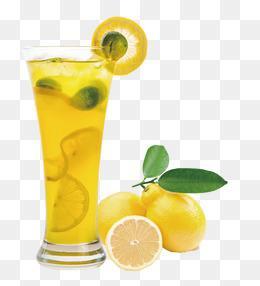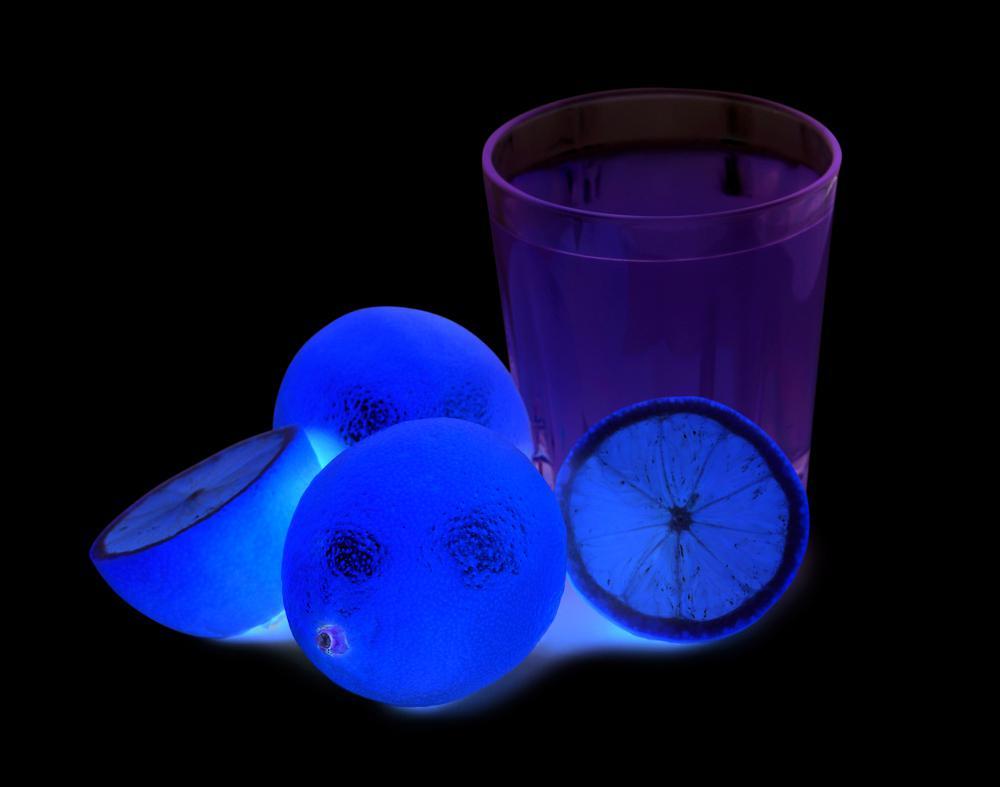The first image is the image on the left, the second image is the image on the right. For the images shown, is this caption "One image includes a whole and half lemon and two green leaves by a yellow beverage in a glass with a flared top." true? Answer yes or no. Yes. The first image is the image on the left, the second image is the image on the right. Evaluate the accuracy of this statement regarding the images: "There is a glass of lemonade with lemons next to it, there is 1/2 of a lemon and the lemon greens from the fruit are visible, the glass is smaller around on the bottom and tapers wider at the top". Is it true? Answer yes or no. Yes. 